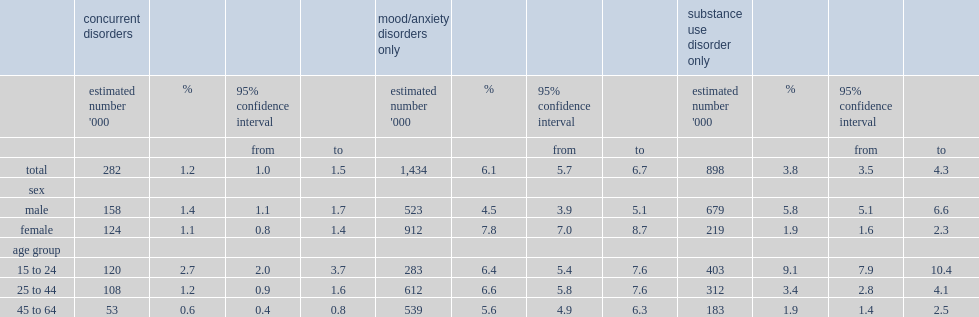What is the estimated percentage of the canadian household population aged 15 to 64 had a mood/anxiety disorder in the previous year? 6.1. What is the estimated percentage of the canadian household population aged 15 to 64 had a substance use disorder in the previous year? 3.8. What is the percentage of men had concurrent disorders? 1.4. What is the percentage of women had concurrent disorders? 1.1. Who were more likely to have a mood/anxiety disorder? Female. Who were more likely to have a substance use disorders? Male. Which group ages peaked at the prevalence of mood/anxiety disorders? 25 to 44. 